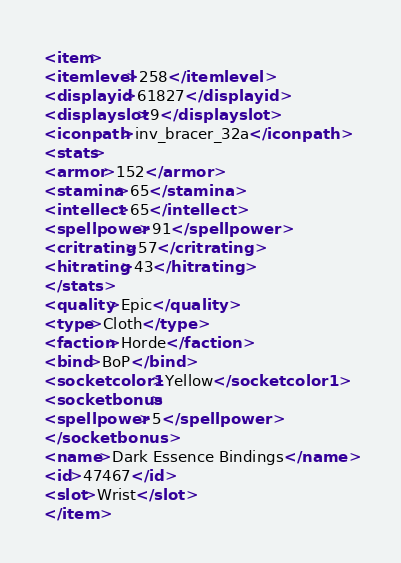<code> <loc_0><loc_0><loc_500><loc_500><_XML_><item>
<itemlevel>258</itemlevel>
<displayid>61827</displayid>
<displayslot>9</displayslot>
<iconpath>inv_bracer_32a</iconpath>
<stats>
<armor>152</armor>
<stamina>65</stamina>
<intellect>65</intellect>
<spellpower>91</spellpower>
<critrating>57</critrating>
<hitrating>43</hitrating>
</stats>
<quality>Epic</quality>
<type>Cloth</type>
<faction>Horde</faction>
<bind>BoP</bind>
<socketcolor1>Yellow</socketcolor1>
<socketbonus>
<spellpower>5</spellpower>
</socketbonus>
<name>Dark Essence Bindings</name>
<id>47467</id>
<slot>Wrist</slot>
</item></code> 